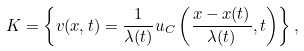<formula> <loc_0><loc_0><loc_500><loc_500>K = \left \{ v ( x , t ) = \frac { 1 } { \lambda ( t ) } u _ { C } \left ( \frac { x - x ( t ) } { \lambda ( t ) } , t \right ) \right \} ,</formula> 